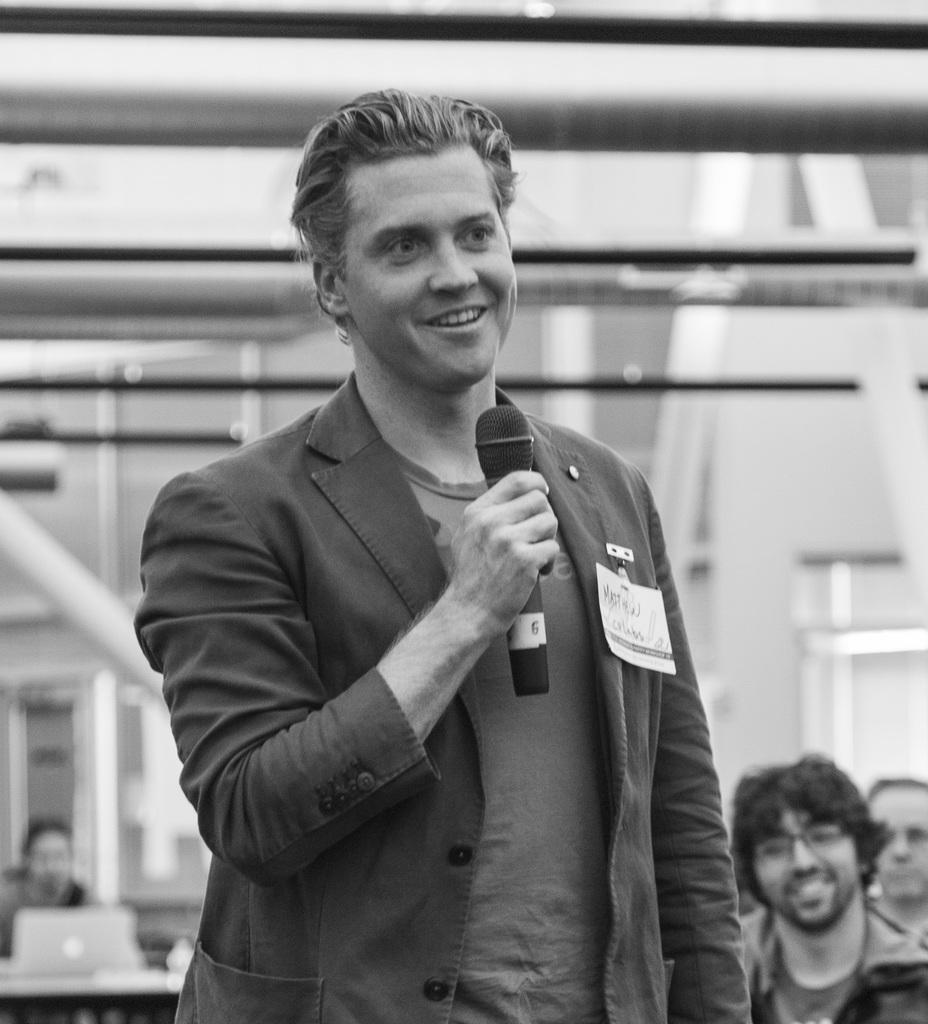Please provide a concise description of this image. This is a black and white image. Here I can see a man standing, holding a mike in the hand and smiling by looking at the right side. In the background, I can see some more people. The background is blurred. 